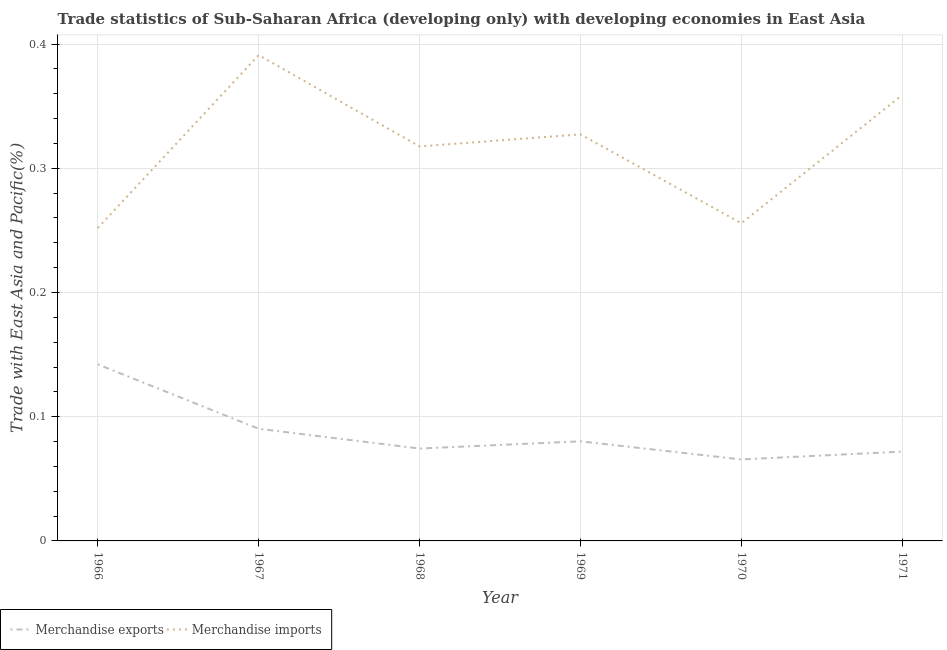Does the line corresponding to merchandise imports intersect with the line corresponding to merchandise exports?
Provide a succinct answer. No. What is the merchandise exports in 1969?
Provide a short and direct response. 0.08. Across all years, what is the maximum merchandise exports?
Give a very brief answer. 0.14. Across all years, what is the minimum merchandise exports?
Provide a succinct answer. 0.07. In which year was the merchandise exports maximum?
Ensure brevity in your answer.  1966. In which year was the merchandise exports minimum?
Offer a terse response. 1970. What is the total merchandise imports in the graph?
Provide a succinct answer. 1.9. What is the difference between the merchandise imports in 1967 and that in 1971?
Your answer should be compact. 0.03. What is the difference between the merchandise exports in 1966 and the merchandise imports in 1967?
Keep it short and to the point. -0.25. What is the average merchandise imports per year?
Provide a short and direct response. 0.32. In the year 1969, what is the difference between the merchandise imports and merchandise exports?
Offer a very short reply. 0.25. In how many years, is the merchandise exports greater than 0.12000000000000001 %?
Give a very brief answer. 1. What is the ratio of the merchandise imports in 1966 to that in 1969?
Your answer should be very brief. 0.77. Is the difference between the merchandise imports in 1966 and 1969 greater than the difference between the merchandise exports in 1966 and 1969?
Give a very brief answer. No. What is the difference between the highest and the second highest merchandise exports?
Offer a very short reply. 0.05. What is the difference between the highest and the lowest merchandise exports?
Offer a very short reply. 0.08. Is the sum of the merchandise exports in 1966 and 1971 greater than the maximum merchandise imports across all years?
Provide a succinct answer. No. Is the merchandise exports strictly greater than the merchandise imports over the years?
Your response must be concise. No. How many lines are there?
Your answer should be compact. 2. What is the difference between two consecutive major ticks on the Y-axis?
Offer a very short reply. 0.1. Does the graph contain any zero values?
Your answer should be compact. No. Where does the legend appear in the graph?
Offer a terse response. Bottom left. How many legend labels are there?
Offer a very short reply. 2. What is the title of the graph?
Your response must be concise. Trade statistics of Sub-Saharan Africa (developing only) with developing economies in East Asia. What is the label or title of the Y-axis?
Keep it short and to the point. Trade with East Asia and Pacific(%). What is the Trade with East Asia and Pacific(%) in Merchandise exports in 1966?
Offer a very short reply. 0.14. What is the Trade with East Asia and Pacific(%) of Merchandise imports in 1966?
Make the answer very short. 0.25. What is the Trade with East Asia and Pacific(%) in Merchandise exports in 1967?
Offer a very short reply. 0.09. What is the Trade with East Asia and Pacific(%) in Merchandise imports in 1967?
Your answer should be very brief. 0.39. What is the Trade with East Asia and Pacific(%) in Merchandise exports in 1968?
Your answer should be very brief. 0.07. What is the Trade with East Asia and Pacific(%) in Merchandise imports in 1968?
Give a very brief answer. 0.32. What is the Trade with East Asia and Pacific(%) of Merchandise exports in 1969?
Give a very brief answer. 0.08. What is the Trade with East Asia and Pacific(%) of Merchandise imports in 1969?
Offer a very short reply. 0.33. What is the Trade with East Asia and Pacific(%) of Merchandise exports in 1970?
Offer a terse response. 0.07. What is the Trade with East Asia and Pacific(%) of Merchandise imports in 1970?
Offer a very short reply. 0.26. What is the Trade with East Asia and Pacific(%) of Merchandise exports in 1971?
Keep it short and to the point. 0.07. What is the Trade with East Asia and Pacific(%) in Merchandise imports in 1971?
Provide a succinct answer. 0.36. Across all years, what is the maximum Trade with East Asia and Pacific(%) of Merchandise exports?
Keep it short and to the point. 0.14. Across all years, what is the maximum Trade with East Asia and Pacific(%) of Merchandise imports?
Ensure brevity in your answer.  0.39. Across all years, what is the minimum Trade with East Asia and Pacific(%) in Merchandise exports?
Your answer should be compact. 0.07. Across all years, what is the minimum Trade with East Asia and Pacific(%) of Merchandise imports?
Your answer should be compact. 0.25. What is the total Trade with East Asia and Pacific(%) of Merchandise exports in the graph?
Make the answer very short. 0.52. What is the total Trade with East Asia and Pacific(%) of Merchandise imports in the graph?
Give a very brief answer. 1.9. What is the difference between the Trade with East Asia and Pacific(%) of Merchandise exports in 1966 and that in 1967?
Your response must be concise. 0.05. What is the difference between the Trade with East Asia and Pacific(%) of Merchandise imports in 1966 and that in 1967?
Make the answer very short. -0.14. What is the difference between the Trade with East Asia and Pacific(%) of Merchandise exports in 1966 and that in 1968?
Offer a terse response. 0.07. What is the difference between the Trade with East Asia and Pacific(%) of Merchandise imports in 1966 and that in 1968?
Ensure brevity in your answer.  -0.07. What is the difference between the Trade with East Asia and Pacific(%) in Merchandise exports in 1966 and that in 1969?
Ensure brevity in your answer.  0.06. What is the difference between the Trade with East Asia and Pacific(%) of Merchandise imports in 1966 and that in 1969?
Offer a very short reply. -0.08. What is the difference between the Trade with East Asia and Pacific(%) in Merchandise exports in 1966 and that in 1970?
Offer a terse response. 0.08. What is the difference between the Trade with East Asia and Pacific(%) in Merchandise imports in 1966 and that in 1970?
Your response must be concise. -0. What is the difference between the Trade with East Asia and Pacific(%) of Merchandise exports in 1966 and that in 1971?
Provide a succinct answer. 0.07. What is the difference between the Trade with East Asia and Pacific(%) in Merchandise imports in 1966 and that in 1971?
Offer a very short reply. -0.11. What is the difference between the Trade with East Asia and Pacific(%) of Merchandise exports in 1967 and that in 1968?
Provide a succinct answer. 0.02. What is the difference between the Trade with East Asia and Pacific(%) in Merchandise imports in 1967 and that in 1968?
Provide a succinct answer. 0.07. What is the difference between the Trade with East Asia and Pacific(%) of Merchandise exports in 1967 and that in 1969?
Your response must be concise. 0.01. What is the difference between the Trade with East Asia and Pacific(%) of Merchandise imports in 1967 and that in 1969?
Give a very brief answer. 0.06. What is the difference between the Trade with East Asia and Pacific(%) of Merchandise exports in 1967 and that in 1970?
Offer a terse response. 0.02. What is the difference between the Trade with East Asia and Pacific(%) in Merchandise imports in 1967 and that in 1970?
Your response must be concise. 0.14. What is the difference between the Trade with East Asia and Pacific(%) of Merchandise exports in 1967 and that in 1971?
Ensure brevity in your answer.  0.02. What is the difference between the Trade with East Asia and Pacific(%) in Merchandise imports in 1967 and that in 1971?
Offer a very short reply. 0.03. What is the difference between the Trade with East Asia and Pacific(%) in Merchandise exports in 1968 and that in 1969?
Your answer should be very brief. -0.01. What is the difference between the Trade with East Asia and Pacific(%) in Merchandise imports in 1968 and that in 1969?
Offer a terse response. -0.01. What is the difference between the Trade with East Asia and Pacific(%) in Merchandise exports in 1968 and that in 1970?
Keep it short and to the point. 0.01. What is the difference between the Trade with East Asia and Pacific(%) in Merchandise imports in 1968 and that in 1970?
Offer a terse response. 0.06. What is the difference between the Trade with East Asia and Pacific(%) in Merchandise exports in 1968 and that in 1971?
Offer a very short reply. 0. What is the difference between the Trade with East Asia and Pacific(%) of Merchandise imports in 1968 and that in 1971?
Your answer should be compact. -0.04. What is the difference between the Trade with East Asia and Pacific(%) in Merchandise exports in 1969 and that in 1970?
Your answer should be very brief. 0.01. What is the difference between the Trade with East Asia and Pacific(%) of Merchandise imports in 1969 and that in 1970?
Provide a short and direct response. 0.07. What is the difference between the Trade with East Asia and Pacific(%) of Merchandise exports in 1969 and that in 1971?
Make the answer very short. 0.01. What is the difference between the Trade with East Asia and Pacific(%) in Merchandise imports in 1969 and that in 1971?
Your answer should be very brief. -0.03. What is the difference between the Trade with East Asia and Pacific(%) of Merchandise exports in 1970 and that in 1971?
Offer a terse response. -0.01. What is the difference between the Trade with East Asia and Pacific(%) of Merchandise imports in 1970 and that in 1971?
Make the answer very short. -0.1. What is the difference between the Trade with East Asia and Pacific(%) in Merchandise exports in 1966 and the Trade with East Asia and Pacific(%) in Merchandise imports in 1967?
Keep it short and to the point. -0.25. What is the difference between the Trade with East Asia and Pacific(%) in Merchandise exports in 1966 and the Trade with East Asia and Pacific(%) in Merchandise imports in 1968?
Make the answer very short. -0.18. What is the difference between the Trade with East Asia and Pacific(%) in Merchandise exports in 1966 and the Trade with East Asia and Pacific(%) in Merchandise imports in 1969?
Your response must be concise. -0.19. What is the difference between the Trade with East Asia and Pacific(%) of Merchandise exports in 1966 and the Trade with East Asia and Pacific(%) of Merchandise imports in 1970?
Your response must be concise. -0.11. What is the difference between the Trade with East Asia and Pacific(%) of Merchandise exports in 1966 and the Trade with East Asia and Pacific(%) of Merchandise imports in 1971?
Provide a short and direct response. -0.22. What is the difference between the Trade with East Asia and Pacific(%) of Merchandise exports in 1967 and the Trade with East Asia and Pacific(%) of Merchandise imports in 1968?
Offer a terse response. -0.23. What is the difference between the Trade with East Asia and Pacific(%) in Merchandise exports in 1967 and the Trade with East Asia and Pacific(%) in Merchandise imports in 1969?
Provide a succinct answer. -0.24. What is the difference between the Trade with East Asia and Pacific(%) in Merchandise exports in 1967 and the Trade with East Asia and Pacific(%) in Merchandise imports in 1970?
Your answer should be compact. -0.17. What is the difference between the Trade with East Asia and Pacific(%) of Merchandise exports in 1967 and the Trade with East Asia and Pacific(%) of Merchandise imports in 1971?
Offer a terse response. -0.27. What is the difference between the Trade with East Asia and Pacific(%) in Merchandise exports in 1968 and the Trade with East Asia and Pacific(%) in Merchandise imports in 1969?
Keep it short and to the point. -0.25. What is the difference between the Trade with East Asia and Pacific(%) in Merchandise exports in 1968 and the Trade with East Asia and Pacific(%) in Merchandise imports in 1970?
Offer a terse response. -0.18. What is the difference between the Trade with East Asia and Pacific(%) in Merchandise exports in 1968 and the Trade with East Asia and Pacific(%) in Merchandise imports in 1971?
Offer a very short reply. -0.28. What is the difference between the Trade with East Asia and Pacific(%) in Merchandise exports in 1969 and the Trade with East Asia and Pacific(%) in Merchandise imports in 1970?
Provide a short and direct response. -0.18. What is the difference between the Trade with East Asia and Pacific(%) in Merchandise exports in 1969 and the Trade with East Asia and Pacific(%) in Merchandise imports in 1971?
Your response must be concise. -0.28. What is the difference between the Trade with East Asia and Pacific(%) in Merchandise exports in 1970 and the Trade with East Asia and Pacific(%) in Merchandise imports in 1971?
Your answer should be compact. -0.29. What is the average Trade with East Asia and Pacific(%) of Merchandise exports per year?
Give a very brief answer. 0.09. What is the average Trade with East Asia and Pacific(%) of Merchandise imports per year?
Provide a succinct answer. 0.32. In the year 1966, what is the difference between the Trade with East Asia and Pacific(%) in Merchandise exports and Trade with East Asia and Pacific(%) in Merchandise imports?
Keep it short and to the point. -0.11. In the year 1967, what is the difference between the Trade with East Asia and Pacific(%) in Merchandise exports and Trade with East Asia and Pacific(%) in Merchandise imports?
Your answer should be compact. -0.3. In the year 1968, what is the difference between the Trade with East Asia and Pacific(%) in Merchandise exports and Trade with East Asia and Pacific(%) in Merchandise imports?
Offer a very short reply. -0.24. In the year 1969, what is the difference between the Trade with East Asia and Pacific(%) of Merchandise exports and Trade with East Asia and Pacific(%) of Merchandise imports?
Make the answer very short. -0.25. In the year 1970, what is the difference between the Trade with East Asia and Pacific(%) of Merchandise exports and Trade with East Asia and Pacific(%) of Merchandise imports?
Make the answer very short. -0.19. In the year 1971, what is the difference between the Trade with East Asia and Pacific(%) in Merchandise exports and Trade with East Asia and Pacific(%) in Merchandise imports?
Offer a terse response. -0.29. What is the ratio of the Trade with East Asia and Pacific(%) in Merchandise exports in 1966 to that in 1967?
Make the answer very short. 1.57. What is the ratio of the Trade with East Asia and Pacific(%) of Merchandise imports in 1966 to that in 1967?
Make the answer very short. 0.64. What is the ratio of the Trade with East Asia and Pacific(%) of Merchandise exports in 1966 to that in 1968?
Your response must be concise. 1.91. What is the ratio of the Trade with East Asia and Pacific(%) of Merchandise imports in 1966 to that in 1968?
Ensure brevity in your answer.  0.79. What is the ratio of the Trade with East Asia and Pacific(%) of Merchandise exports in 1966 to that in 1969?
Your response must be concise. 1.77. What is the ratio of the Trade with East Asia and Pacific(%) in Merchandise imports in 1966 to that in 1969?
Provide a short and direct response. 0.77. What is the ratio of the Trade with East Asia and Pacific(%) in Merchandise exports in 1966 to that in 1970?
Provide a succinct answer. 2.17. What is the ratio of the Trade with East Asia and Pacific(%) in Merchandise imports in 1966 to that in 1970?
Make the answer very short. 0.98. What is the ratio of the Trade with East Asia and Pacific(%) of Merchandise exports in 1966 to that in 1971?
Offer a terse response. 1.98. What is the ratio of the Trade with East Asia and Pacific(%) in Merchandise imports in 1966 to that in 1971?
Provide a short and direct response. 0.7. What is the ratio of the Trade with East Asia and Pacific(%) of Merchandise exports in 1967 to that in 1968?
Provide a short and direct response. 1.21. What is the ratio of the Trade with East Asia and Pacific(%) of Merchandise imports in 1967 to that in 1968?
Ensure brevity in your answer.  1.23. What is the ratio of the Trade with East Asia and Pacific(%) of Merchandise exports in 1967 to that in 1969?
Ensure brevity in your answer.  1.13. What is the ratio of the Trade with East Asia and Pacific(%) of Merchandise imports in 1967 to that in 1969?
Keep it short and to the point. 1.2. What is the ratio of the Trade with East Asia and Pacific(%) in Merchandise exports in 1967 to that in 1970?
Keep it short and to the point. 1.38. What is the ratio of the Trade with East Asia and Pacific(%) in Merchandise imports in 1967 to that in 1970?
Make the answer very short. 1.53. What is the ratio of the Trade with East Asia and Pacific(%) in Merchandise exports in 1967 to that in 1971?
Provide a succinct answer. 1.26. What is the ratio of the Trade with East Asia and Pacific(%) of Merchandise imports in 1967 to that in 1971?
Ensure brevity in your answer.  1.09. What is the ratio of the Trade with East Asia and Pacific(%) in Merchandise exports in 1968 to that in 1969?
Offer a terse response. 0.93. What is the ratio of the Trade with East Asia and Pacific(%) of Merchandise imports in 1968 to that in 1969?
Your answer should be very brief. 0.97. What is the ratio of the Trade with East Asia and Pacific(%) in Merchandise exports in 1968 to that in 1970?
Provide a short and direct response. 1.13. What is the ratio of the Trade with East Asia and Pacific(%) of Merchandise imports in 1968 to that in 1970?
Provide a short and direct response. 1.24. What is the ratio of the Trade with East Asia and Pacific(%) of Merchandise exports in 1968 to that in 1971?
Offer a terse response. 1.03. What is the ratio of the Trade with East Asia and Pacific(%) of Merchandise imports in 1968 to that in 1971?
Offer a very short reply. 0.88. What is the ratio of the Trade with East Asia and Pacific(%) of Merchandise exports in 1969 to that in 1970?
Your response must be concise. 1.22. What is the ratio of the Trade with East Asia and Pacific(%) in Merchandise imports in 1969 to that in 1970?
Offer a terse response. 1.28. What is the ratio of the Trade with East Asia and Pacific(%) in Merchandise exports in 1969 to that in 1971?
Your answer should be very brief. 1.11. What is the ratio of the Trade with East Asia and Pacific(%) of Merchandise imports in 1969 to that in 1971?
Your answer should be very brief. 0.91. What is the ratio of the Trade with East Asia and Pacific(%) in Merchandise exports in 1970 to that in 1971?
Provide a succinct answer. 0.91. What is the ratio of the Trade with East Asia and Pacific(%) in Merchandise imports in 1970 to that in 1971?
Provide a succinct answer. 0.71. What is the difference between the highest and the second highest Trade with East Asia and Pacific(%) of Merchandise exports?
Offer a very short reply. 0.05. What is the difference between the highest and the second highest Trade with East Asia and Pacific(%) in Merchandise imports?
Your answer should be compact. 0.03. What is the difference between the highest and the lowest Trade with East Asia and Pacific(%) of Merchandise exports?
Offer a terse response. 0.08. What is the difference between the highest and the lowest Trade with East Asia and Pacific(%) in Merchandise imports?
Make the answer very short. 0.14. 